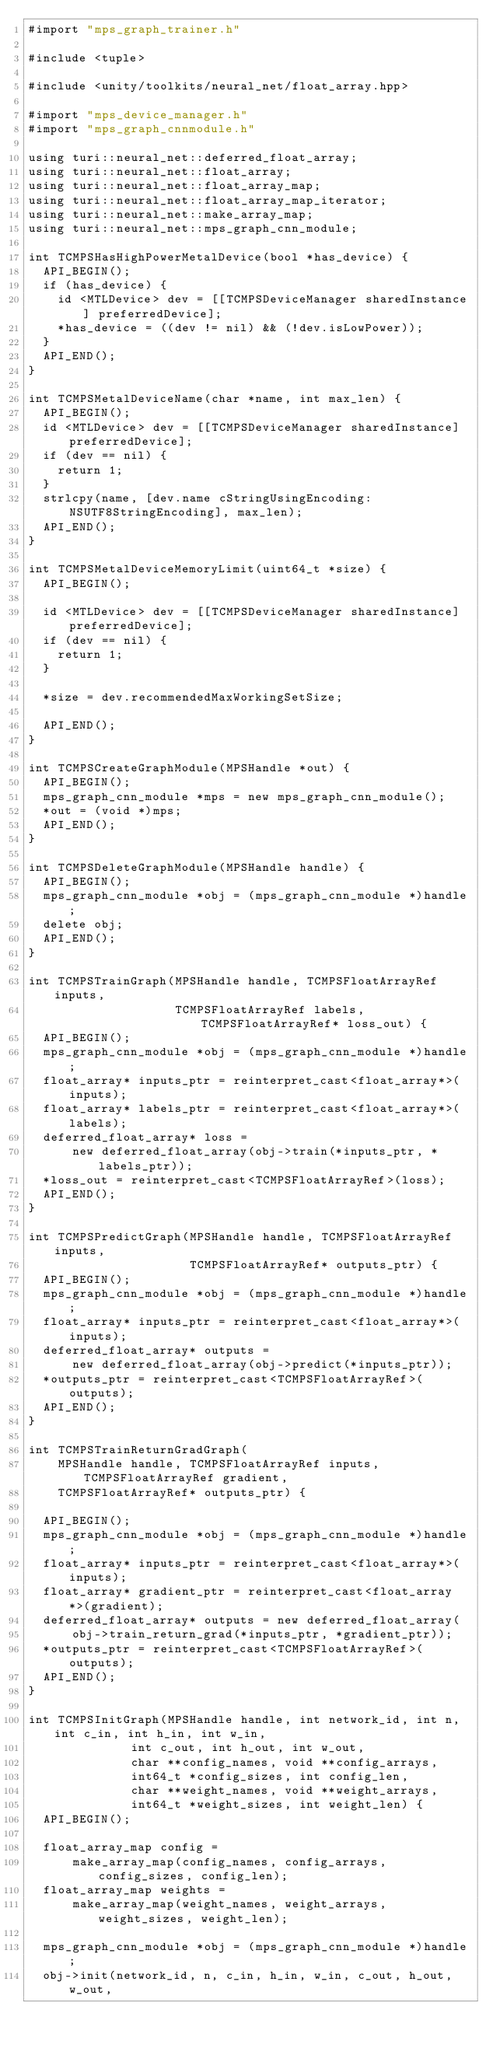<code> <loc_0><loc_0><loc_500><loc_500><_ObjectiveC_>#import "mps_graph_trainer.h"

#include <tuple>

#include <unity/toolkits/neural_net/float_array.hpp>

#import "mps_device_manager.h"
#import "mps_graph_cnnmodule.h"

using turi::neural_net::deferred_float_array;
using turi::neural_net::float_array;
using turi::neural_net::float_array_map;
using turi::neural_net::float_array_map_iterator;
using turi::neural_net::make_array_map;
using turi::neural_net::mps_graph_cnn_module;

int TCMPSHasHighPowerMetalDevice(bool *has_device) {
  API_BEGIN();
  if (has_device) {
    id <MTLDevice> dev = [[TCMPSDeviceManager sharedInstance] preferredDevice];
    *has_device = ((dev != nil) && (!dev.isLowPower));
  }
  API_END();
}

int TCMPSMetalDeviceName(char *name, int max_len) {
  API_BEGIN();
  id <MTLDevice> dev = [[TCMPSDeviceManager sharedInstance] preferredDevice];
  if (dev == nil) {
    return 1;
  }
  strlcpy(name, [dev.name cStringUsingEncoding:NSUTF8StringEncoding], max_len);
  API_END();
}

int TCMPSMetalDeviceMemoryLimit(uint64_t *size) {
  API_BEGIN();

  id <MTLDevice> dev = [[TCMPSDeviceManager sharedInstance] preferredDevice];
  if (dev == nil) {
    return 1;
  }

  *size = dev.recommendedMaxWorkingSetSize;

  API_END();
}

int TCMPSCreateGraphModule(MPSHandle *out) {
  API_BEGIN();
  mps_graph_cnn_module *mps = new mps_graph_cnn_module();
  *out = (void *)mps;
  API_END();
}

int TCMPSDeleteGraphModule(MPSHandle handle) {
  API_BEGIN();
  mps_graph_cnn_module *obj = (mps_graph_cnn_module *)handle;
  delete obj;
  API_END();
}

int TCMPSTrainGraph(MPSHandle handle, TCMPSFloatArrayRef inputs,
                    TCMPSFloatArrayRef labels, TCMPSFloatArrayRef* loss_out) {
  API_BEGIN();
  mps_graph_cnn_module *obj = (mps_graph_cnn_module *)handle;
  float_array* inputs_ptr = reinterpret_cast<float_array*>(inputs);
  float_array* labels_ptr = reinterpret_cast<float_array*>(labels);
  deferred_float_array* loss =
      new deferred_float_array(obj->train(*inputs_ptr, *labels_ptr));
  *loss_out = reinterpret_cast<TCMPSFloatArrayRef>(loss);
  API_END();
}

int TCMPSPredictGraph(MPSHandle handle, TCMPSFloatArrayRef inputs,
                      TCMPSFloatArrayRef* outputs_ptr) {
  API_BEGIN();
  mps_graph_cnn_module *obj = (mps_graph_cnn_module *)handle;
  float_array* inputs_ptr = reinterpret_cast<float_array*>(inputs);
  deferred_float_array* outputs =
      new deferred_float_array(obj->predict(*inputs_ptr));
  *outputs_ptr = reinterpret_cast<TCMPSFloatArrayRef>(outputs);
  API_END();
}

int TCMPSTrainReturnGradGraph(
    MPSHandle handle, TCMPSFloatArrayRef inputs, TCMPSFloatArrayRef gradient,
    TCMPSFloatArrayRef* outputs_ptr) {

  API_BEGIN();
  mps_graph_cnn_module *obj = (mps_graph_cnn_module *)handle;
  float_array* inputs_ptr = reinterpret_cast<float_array*>(inputs);
  float_array* gradient_ptr = reinterpret_cast<float_array*>(gradient);
  deferred_float_array* outputs = new deferred_float_array(
      obj->train_return_grad(*inputs_ptr, *gradient_ptr));
  *outputs_ptr = reinterpret_cast<TCMPSFloatArrayRef>(outputs);
  API_END();
}

int TCMPSInitGraph(MPSHandle handle, int network_id, int n, int c_in, int h_in, int w_in,
              int c_out, int h_out, int w_out,
              char **config_names, void **config_arrays,
              int64_t *config_sizes, int config_len,
              char **weight_names, void **weight_arrays,
              int64_t *weight_sizes, int weight_len) {
  API_BEGIN();
  
  float_array_map config =
      make_array_map(config_names, config_arrays, config_sizes, config_len);
  float_array_map weights =
      make_array_map(weight_names, weight_arrays, weight_sizes, weight_len);

  mps_graph_cnn_module *obj = (mps_graph_cnn_module *)handle;
  obj->init(network_id, n, c_in, h_in, w_in, c_out, h_out, w_out,</code> 